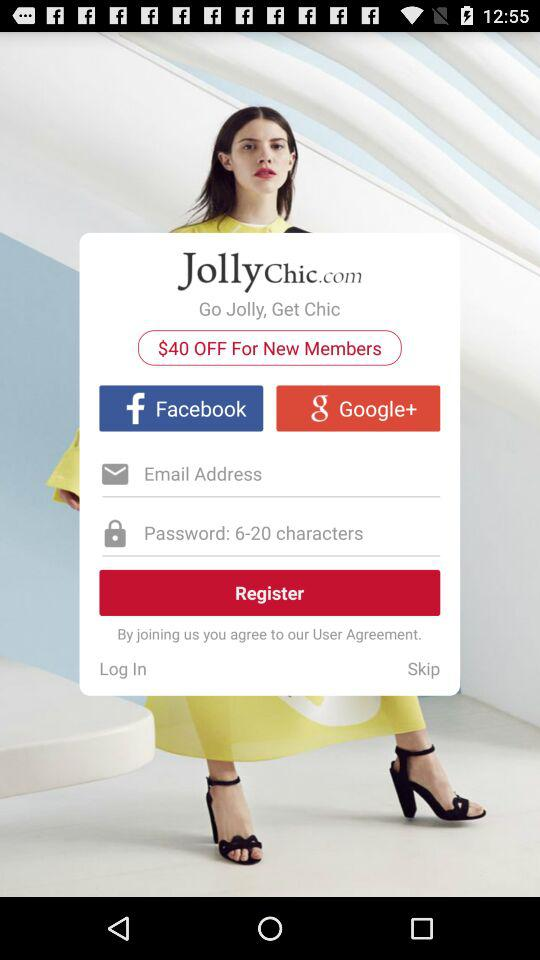How much is off for new members? For new members, $40 is off. 